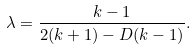<formula> <loc_0><loc_0><loc_500><loc_500>\lambda = \frac { k - 1 } { 2 ( k + 1 ) - D ( k - 1 ) } .</formula> 